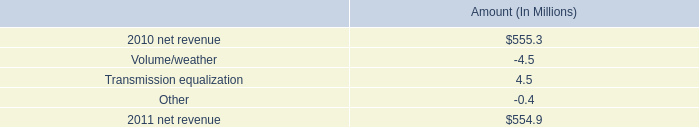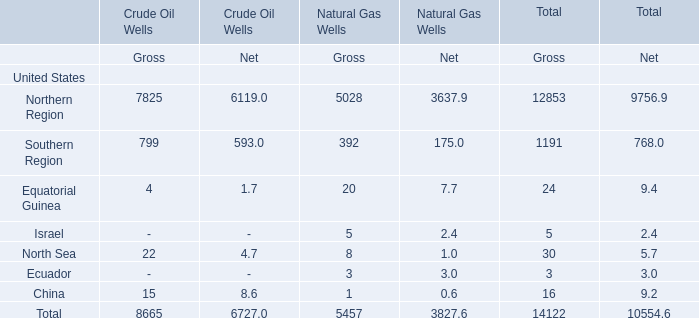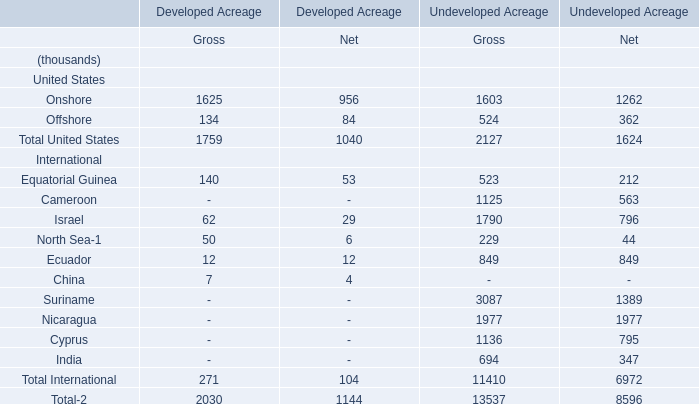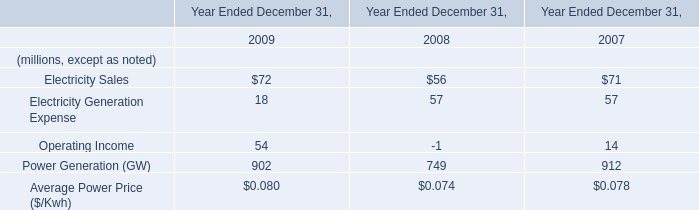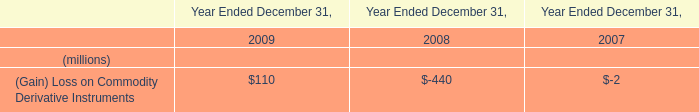What's the total amount of the Electricity Sales and Electricity Generation Expensein the years where (Gain) Loss on Commodity Derivative Instruments is greater than 100? (in million) 
Computations: (72 + 18)
Answer: 90.0. 